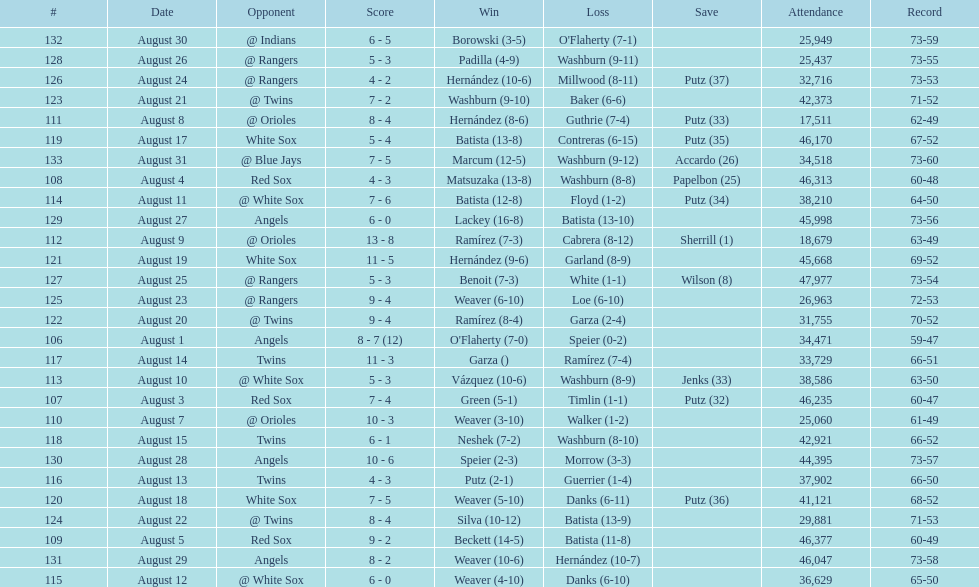Number of wins during stretch 5. 